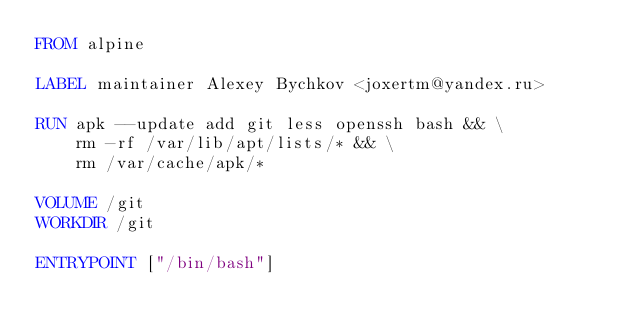<code> <loc_0><loc_0><loc_500><loc_500><_Dockerfile_>FROM alpine

LABEL maintainer Alexey Bychkov <joxertm@yandex.ru>

RUN apk --update add git less openssh bash && \
    rm -rf /var/lib/apt/lists/* && \
    rm /var/cache/apk/*

VOLUME /git
WORKDIR /git

ENTRYPOINT ["/bin/bash"]
</code> 